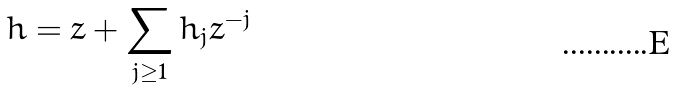<formula> <loc_0><loc_0><loc_500><loc_500>h = z + \sum _ { j \geq 1 } h _ { j } z ^ { - j }</formula> 